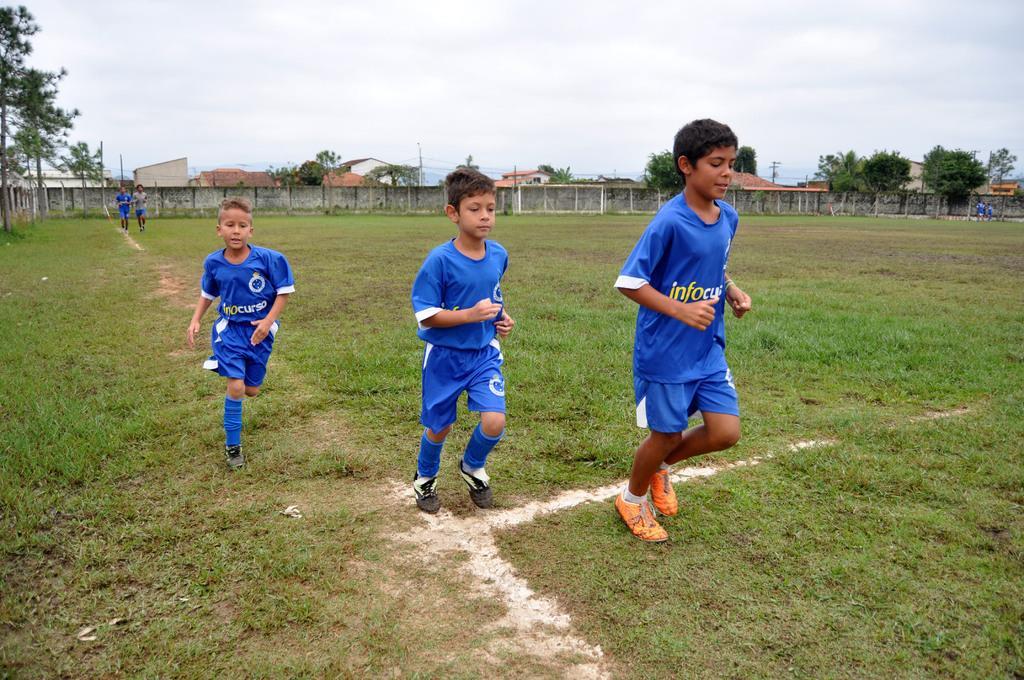Can you describe this image briefly? In the image we can see there are kids standing on the ground and there's grass on the ground. Behind there are buildings and there are trees. There is a cloudy sky. 